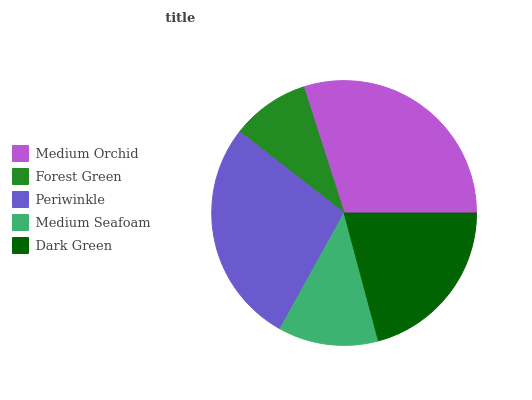Is Forest Green the minimum?
Answer yes or no. Yes. Is Medium Orchid the maximum?
Answer yes or no. Yes. Is Periwinkle the minimum?
Answer yes or no. No. Is Periwinkle the maximum?
Answer yes or no. No. Is Periwinkle greater than Forest Green?
Answer yes or no. Yes. Is Forest Green less than Periwinkle?
Answer yes or no. Yes. Is Forest Green greater than Periwinkle?
Answer yes or no. No. Is Periwinkle less than Forest Green?
Answer yes or no. No. Is Dark Green the high median?
Answer yes or no. Yes. Is Dark Green the low median?
Answer yes or no. Yes. Is Periwinkle the high median?
Answer yes or no. No. Is Medium Orchid the low median?
Answer yes or no. No. 